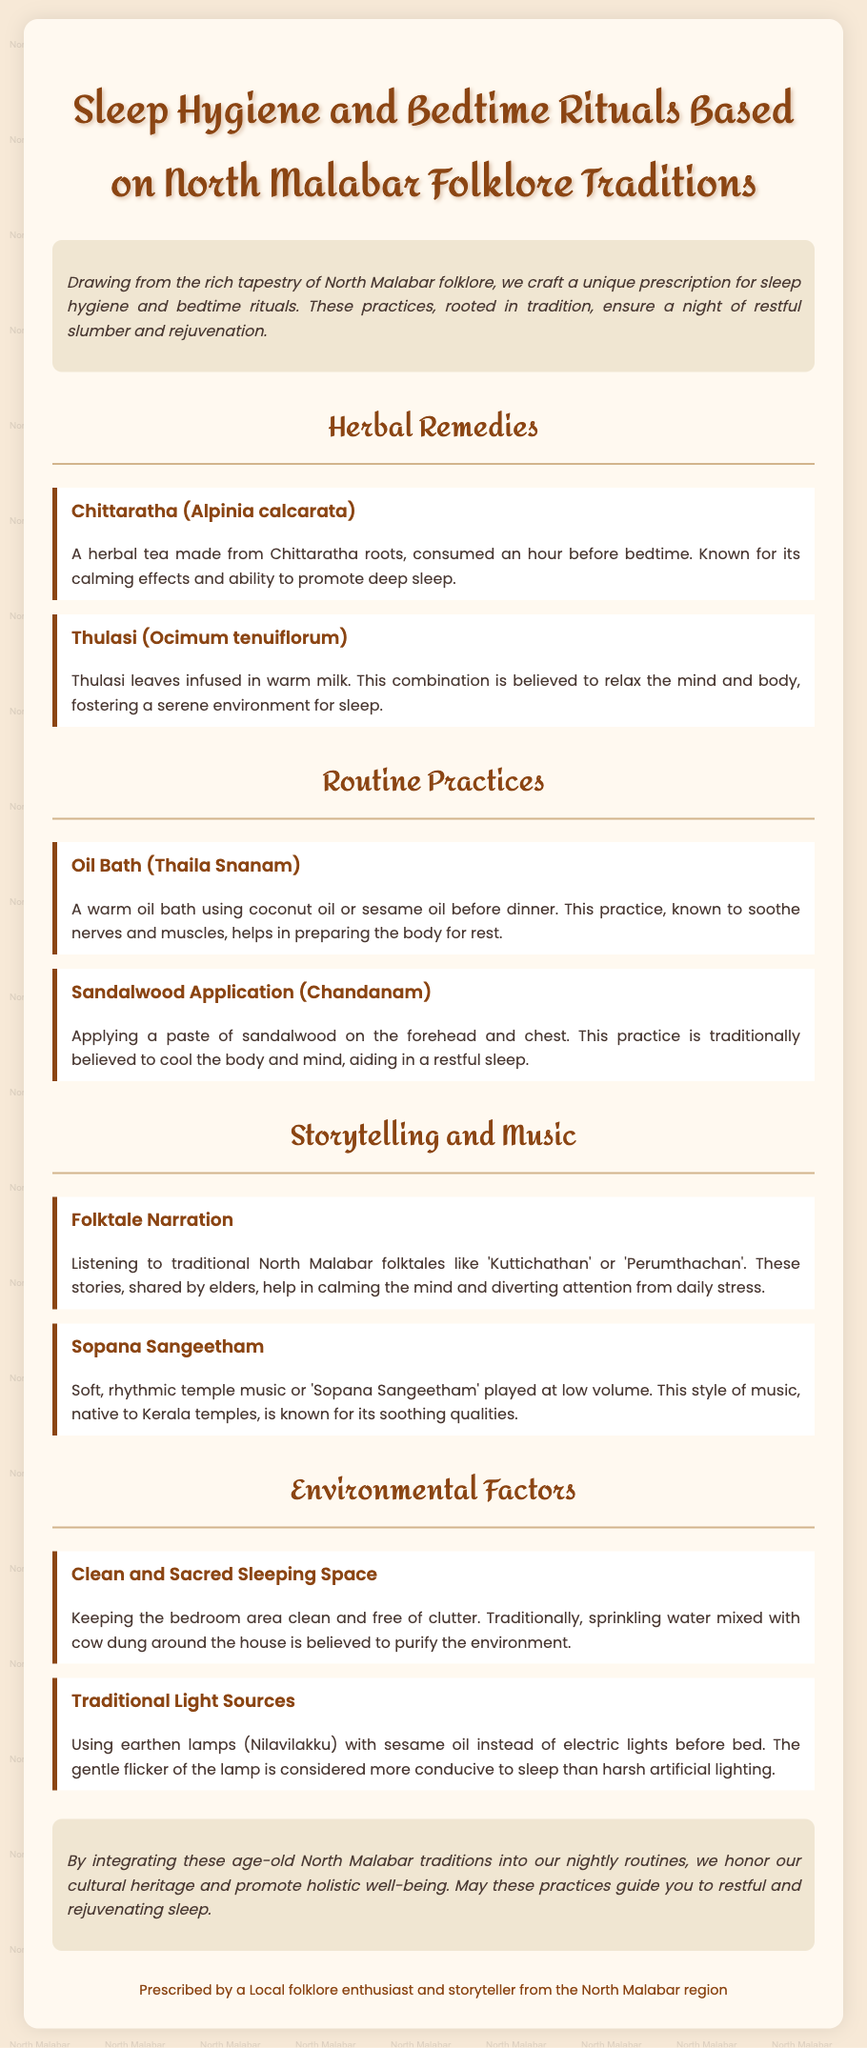What is the title of the document? The title appears prominently at the top of the document and is "Sleep Hygiene and Bedtime Rituals Based on North Malabar Folklore Traditions."
Answer: Sleep Hygiene and Bedtime Rituals Based on North Malabar Folklore Traditions What is the herbal remedy mentioned for calming effects? The document lists herbal remedies, specifically highlighting "Chittaratha" for its calming effects.
Answer: Chittaratha What is recommended to consume an hour before bedtime? The recommendations indicate that a herbal tea made from Chittaratha roots should be consumed an hour before bedtime.
Answer: Herbal tea What does "Thulasi" get infused in? The document states that Thulasi leaves are infused in warm milk for a calming effect.
Answer: Warm milk What practice involves applying sandalwood on the forehead? The document mentions the practice of "Sandalwood Application" or Chandanam which involves this act.
Answer: Sandalwood Application Which type of music is suggested for calming the mind? The document refers to "Sopana Sangeetham" as a soothing type of music intended for relaxation.
Answer: Sopana Sangeetham What should be used instead of electric lights before bed? The document advises using "earthen lamps" with sesame oil instead of electric lights.
Answer: Earthen lamps What is a method used to purify the sleeping environment? The document mentions that traditionally, sprinkling water mixed with cow dung around the house purifies the environment.
Answer: Cow dung Which aspect of sleep hygiene involves maintaining a clean bedroom? The section titled "Clean and Sacred Sleeping Space" discusses this aspect.
Answer: Clean and Sacred Sleeping Space 